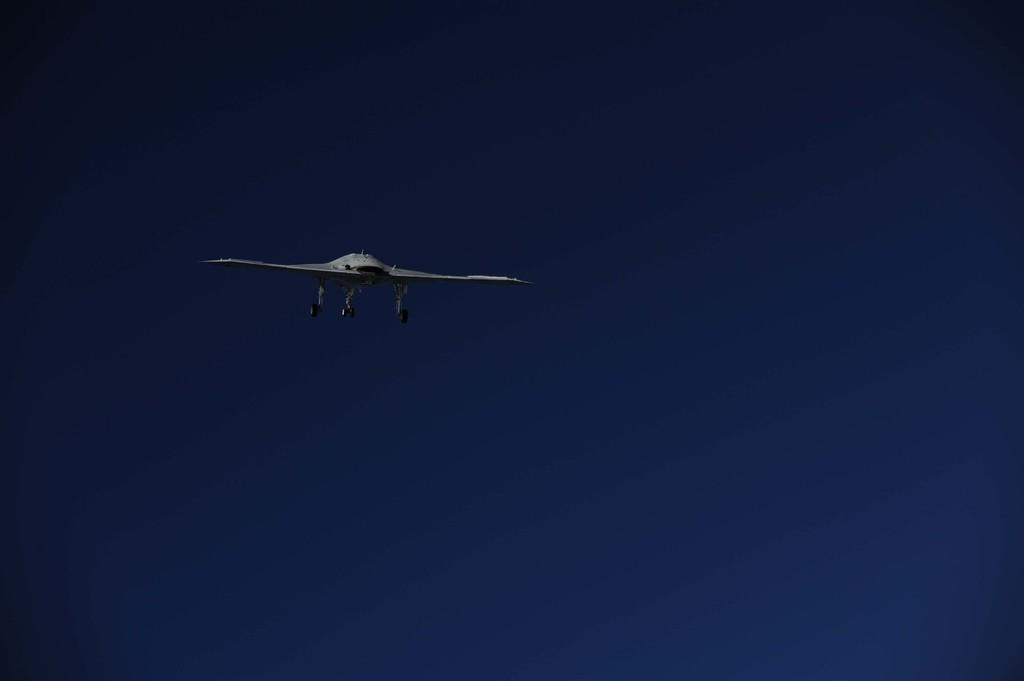What is the main subject of the image? The main subject of the image is an aircraft. Where is the aircraft located in the image? The aircraft is in the sky. What type of music can be heard playing in the library in the image? There is no library or music present in the image; it features an aircraft in the sky. What kind of zephyr is visible in the image? There is no zephyr present in the image. 